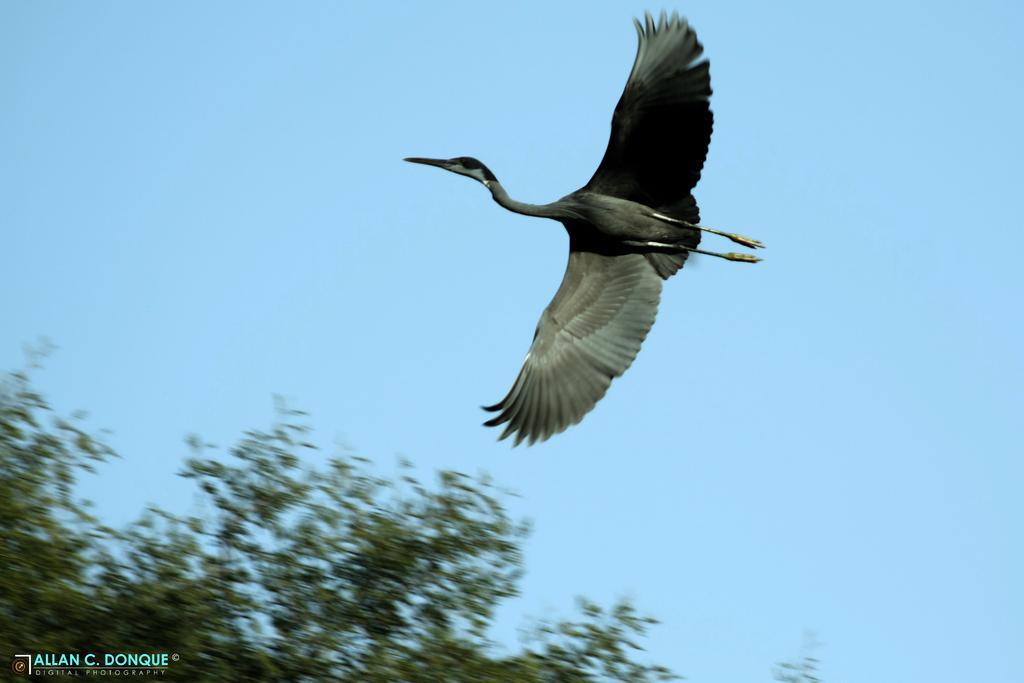Can you describe this image briefly? In the left bottom, we see the trees. In the middle, we see a bird in black and grey color is flying in the sky. In the background, we see the sky, which is blue in color. 